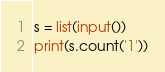Convert code to text. <code><loc_0><loc_0><loc_500><loc_500><_Python_>s = list(input())
print(s.count('1'))</code> 